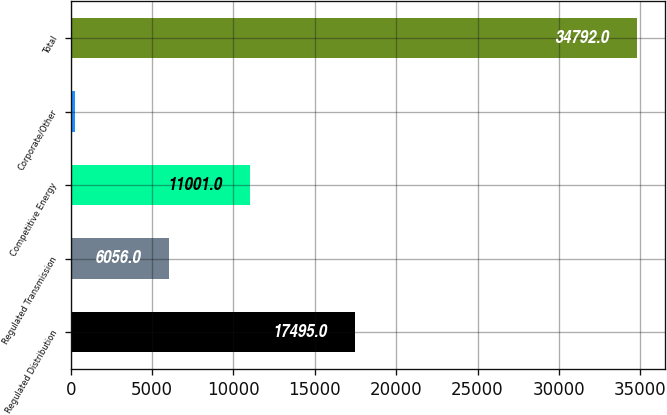Convert chart. <chart><loc_0><loc_0><loc_500><loc_500><bar_chart><fcel>Regulated Distribution<fcel>Regulated Transmission<fcel>Competitive Energy<fcel>Corporate/Other<fcel>Total<nl><fcel>17495<fcel>6056<fcel>11001<fcel>240<fcel>34792<nl></chart> 